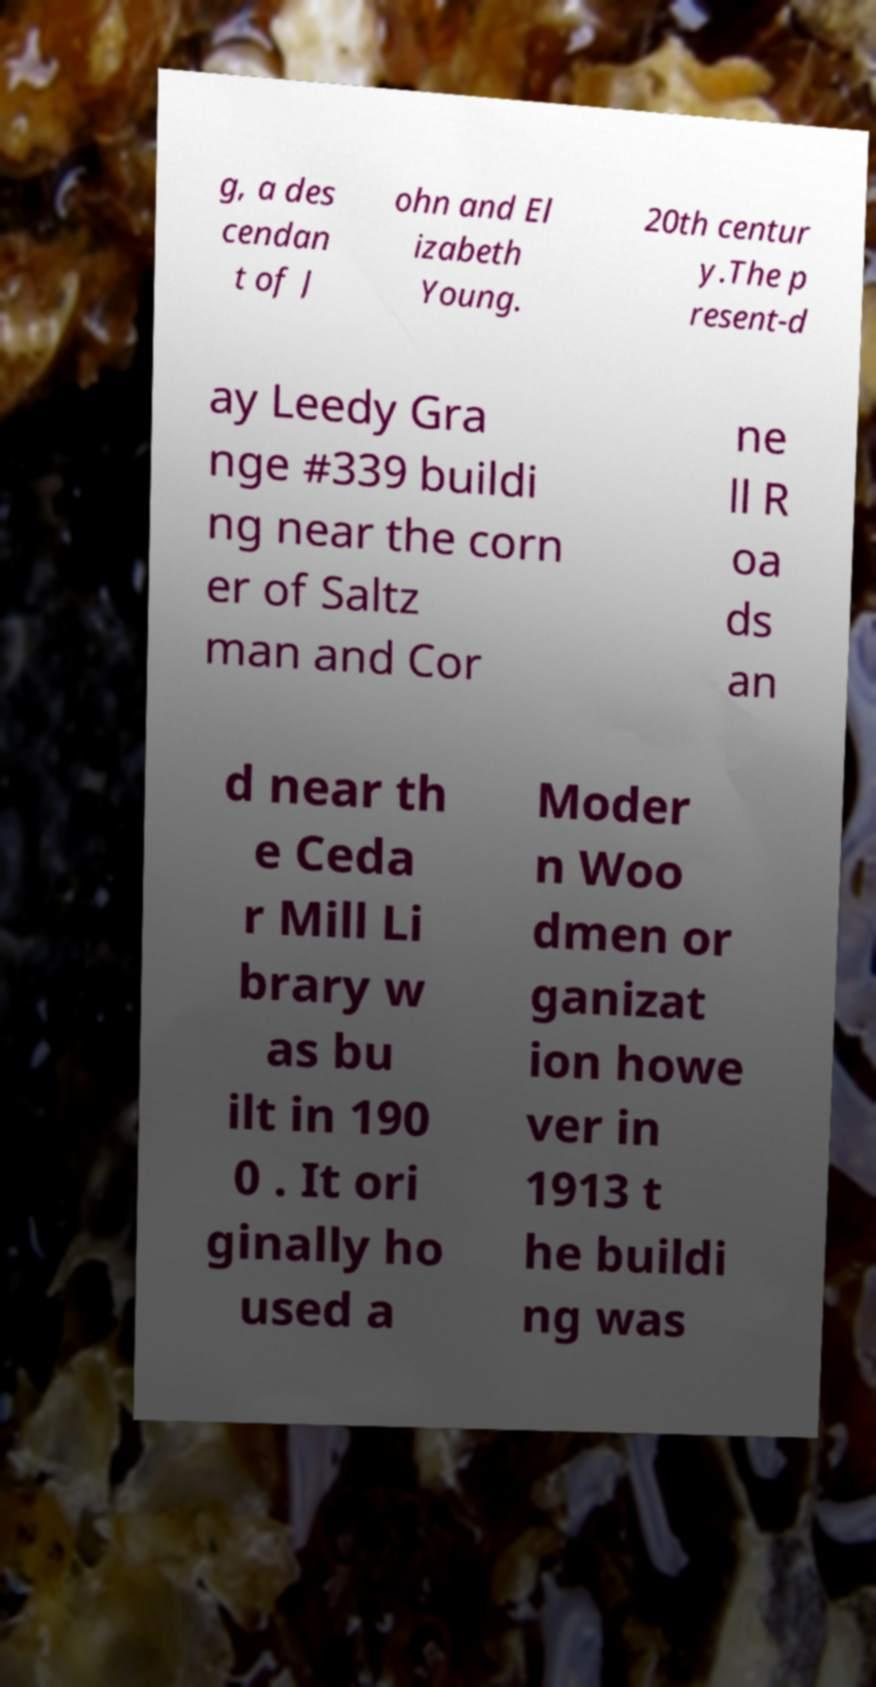Please read and relay the text visible in this image. What does it say? g, a des cendan t of J ohn and El izabeth Young. 20th centur y.The p resent-d ay Leedy Gra nge #339 buildi ng near the corn er of Saltz man and Cor ne ll R oa ds an d near th e Ceda r Mill Li brary w as bu ilt in 190 0 . It ori ginally ho used a Moder n Woo dmen or ganizat ion howe ver in 1913 t he buildi ng was 